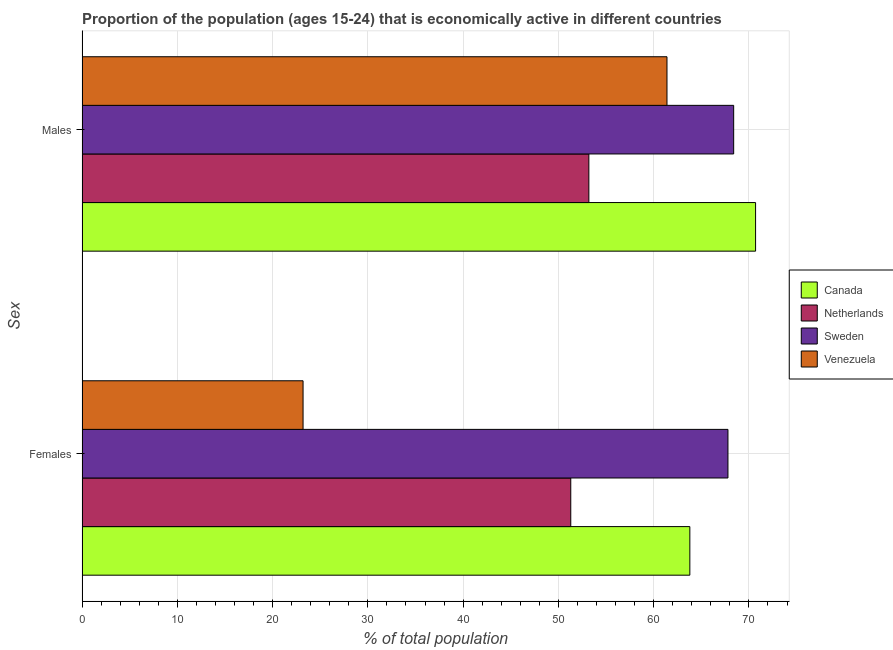Are the number of bars per tick equal to the number of legend labels?
Provide a short and direct response. Yes. How many bars are there on the 2nd tick from the bottom?
Make the answer very short. 4. What is the label of the 2nd group of bars from the top?
Provide a succinct answer. Females. What is the percentage of economically active male population in Sweden?
Keep it short and to the point. 68.4. Across all countries, what is the maximum percentage of economically active female population?
Make the answer very short. 67.8. Across all countries, what is the minimum percentage of economically active female population?
Keep it short and to the point. 23.2. In which country was the percentage of economically active male population minimum?
Keep it short and to the point. Netherlands. What is the total percentage of economically active male population in the graph?
Your response must be concise. 253.7. What is the difference between the percentage of economically active female population in Netherlands and that in Venezuela?
Your answer should be very brief. 28.1. What is the difference between the percentage of economically active male population in Canada and the percentage of economically active female population in Netherlands?
Keep it short and to the point. 19.4. What is the average percentage of economically active male population per country?
Give a very brief answer. 63.43. What is the difference between the percentage of economically active female population and percentage of economically active male population in Netherlands?
Your answer should be very brief. -1.9. What is the ratio of the percentage of economically active female population in Venezuela to that in Canada?
Keep it short and to the point. 0.36. Is the percentage of economically active male population in Netherlands less than that in Sweden?
Ensure brevity in your answer.  Yes. What does the 3rd bar from the top in Females represents?
Provide a short and direct response. Netherlands. How many bars are there?
Your answer should be compact. 8. What is the difference between two consecutive major ticks on the X-axis?
Your answer should be compact. 10. Are the values on the major ticks of X-axis written in scientific E-notation?
Give a very brief answer. No. How are the legend labels stacked?
Provide a short and direct response. Vertical. What is the title of the graph?
Provide a succinct answer. Proportion of the population (ages 15-24) that is economically active in different countries. Does "Euro area" appear as one of the legend labels in the graph?
Provide a short and direct response. No. What is the label or title of the X-axis?
Ensure brevity in your answer.  % of total population. What is the label or title of the Y-axis?
Ensure brevity in your answer.  Sex. What is the % of total population of Canada in Females?
Your response must be concise. 63.8. What is the % of total population in Netherlands in Females?
Your response must be concise. 51.3. What is the % of total population in Sweden in Females?
Your response must be concise. 67.8. What is the % of total population of Venezuela in Females?
Provide a succinct answer. 23.2. What is the % of total population in Canada in Males?
Your response must be concise. 70.7. What is the % of total population in Netherlands in Males?
Provide a succinct answer. 53.2. What is the % of total population in Sweden in Males?
Your answer should be very brief. 68.4. What is the % of total population of Venezuela in Males?
Your answer should be very brief. 61.4. Across all Sex, what is the maximum % of total population in Canada?
Your response must be concise. 70.7. Across all Sex, what is the maximum % of total population in Netherlands?
Provide a succinct answer. 53.2. Across all Sex, what is the maximum % of total population of Sweden?
Offer a terse response. 68.4. Across all Sex, what is the maximum % of total population in Venezuela?
Your answer should be compact. 61.4. Across all Sex, what is the minimum % of total population in Canada?
Your response must be concise. 63.8. Across all Sex, what is the minimum % of total population of Netherlands?
Your response must be concise. 51.3. Across all Sex, what is the minimum % of total population of Sweden?
Provide a succinct answer. 67.8. Across all Sex, what is the minimum % of total population in Venezuela?
Your answer should be compact. 23.2. What is the total % of total population of Canada in the graph?
Give a very brief answer. 134.5. What is the total % of total population of Netherlands in the graph?
Your answer should be compact. 104.5. What is the total % of total population of Sweden in the graph?
Ensure brevity in your answer.  136.2. What is the total % of total population in Venezuela in the graph?
Offer a very short reply. 84.6. What is the difference between the % of total population in Canada in Females and that in Males?
Make the answer very short. -6.9. What is the difference between the % of total population of Netherlands in Females and that in Males?
Your answer should be compact. -1.9. What is the difference between the % of total population of Venezuela in Females and that in Males?
Provide a short and direct response. -38.2. What is the difference between the % of total population of Canada in Females and the % of total population of Netherlands in Males?
Provide a succinct answer. 10.6. What is the difference between the % of total population of Netherlands in Females and the % of total population of Sweden in Males?
Keep it short and to the point. -17.1. What is the difference between the % of total population in Netherlands in Females and the % of total population in Venezuela in Males?
Give a very brief answer. -10.1. What is the difference between the % of total population of Sweden in Females and the % of total population of Venezuela in Males?
Make the answer very short. 6.4. What is the average % of total population in Canada per Sex?
Your response must be concise. 67.25. What is the average % of total population in Netherlands per Sex?
Offer a very short reply. 52.25. What is the average % of total population in Sweden per Sex?
Offer a very short reply. 68.1. What is the average % of total population in Venezuela per Sex?
Give a very brief answer. 42.3. What is the difference between the % of total population in Canada and % of total population in Netherlands in Females?
Your response must be concise. 12.5. What is the difference between the % of total population in Canada and % of total population in Sweden in Females?
Your response must be concise. -4. What is the difference between the % of total population in Canada and % of total population in Venezuela in Females?
Provide a succinct answer. 40.6. What is the difference between the % of total population in Netherlands and % of total population in Sweden in Females?
Your answer should be very brief. -16.5. What is the difference between the % of total population of Netherlands and % of total population of Venezuela in Females?
Give a very brief answer. 28.1. What is the difference between the % of total population in Sweden and % of total population in Venezuela in Females?
Your answer should be very brief. 44.6. What is the difference between the % of total population in Canada and % of total population in Netherlands in Males?
Provide a short and direct response. 17.5. What is the difference between the % of total population of Canada and % of total population of Sweden in Males?
Provide a short and direct response. 2.3. What is the difference between the % of total population in Netherlands and % of total population in Sweden in Males?
Your answer should be compact. -15.2. What is the difference between the % of total population of Netherlands and % of total population of Venezuela in Males?
Provide a succinct answer. -8.2. What is the difference between the % of total population of Sweden and % of total population of Venezuela in Males?
Provide a short and direct response. 7. What is the ratio of the % of total population in Canada in Females to that in Males?
Offer a very short reply. 0.9. What is the ratio of the % of total population in Netherlands in Females to that in Males?
Make the answer very short. 0.96. What is the ratio of the % of total population in Sweden in Females to that in Males?
Offer a terse response. 0.99. What is the ratio of the % of total population in Venezuela in Females to that in Males?
Offer a terse response. 0.38. What is the difference between the highest and the second highest % of total population in Canada?
Your answer should be compact. 6.9. What is the difference between the highest and the second highest % of total population of Venezuela?
Offer a very short reply. 38.2. What is the difference between the highest and the lowest % of total population of Canada?
Keep it short and to the point. 6.9. What is the difference between the highest and the lowest % of total population in Netherlands?
Your answer should be very brief. 1.9. What is the difference between the highest and the lowest % of total population of Venezuela?
Ensure brevity in your answer.  38.2. 